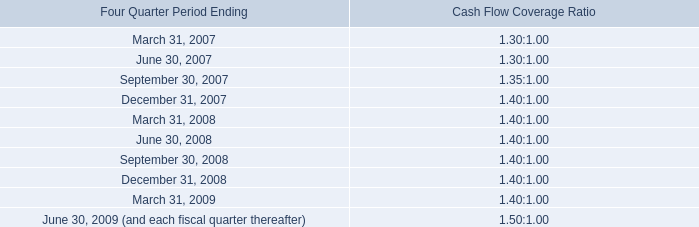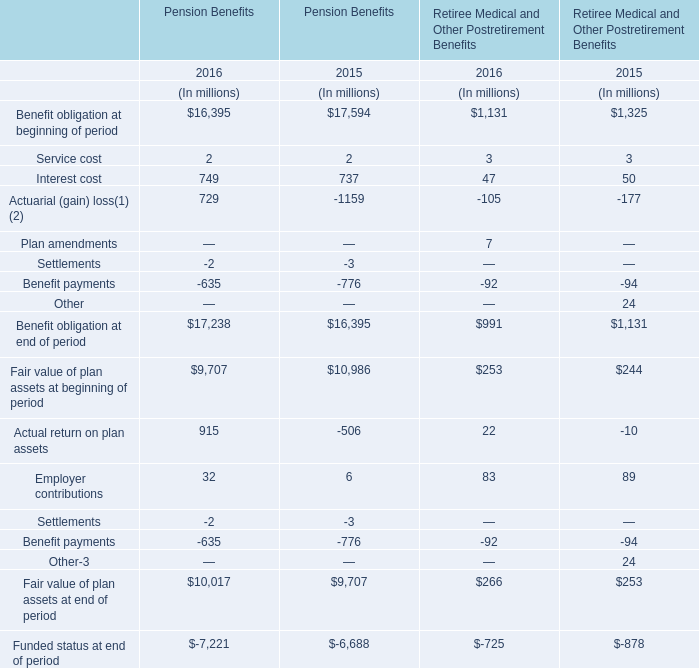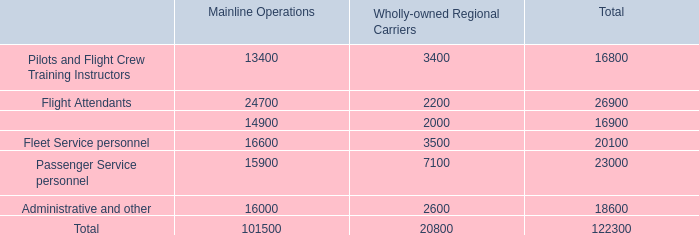What's the increasing rate of Pension Benefits' benefit obligation at beginning of period in 2016? 
Computations: ((16395 - 17594) / 17594)
Answer: -0.06815. 